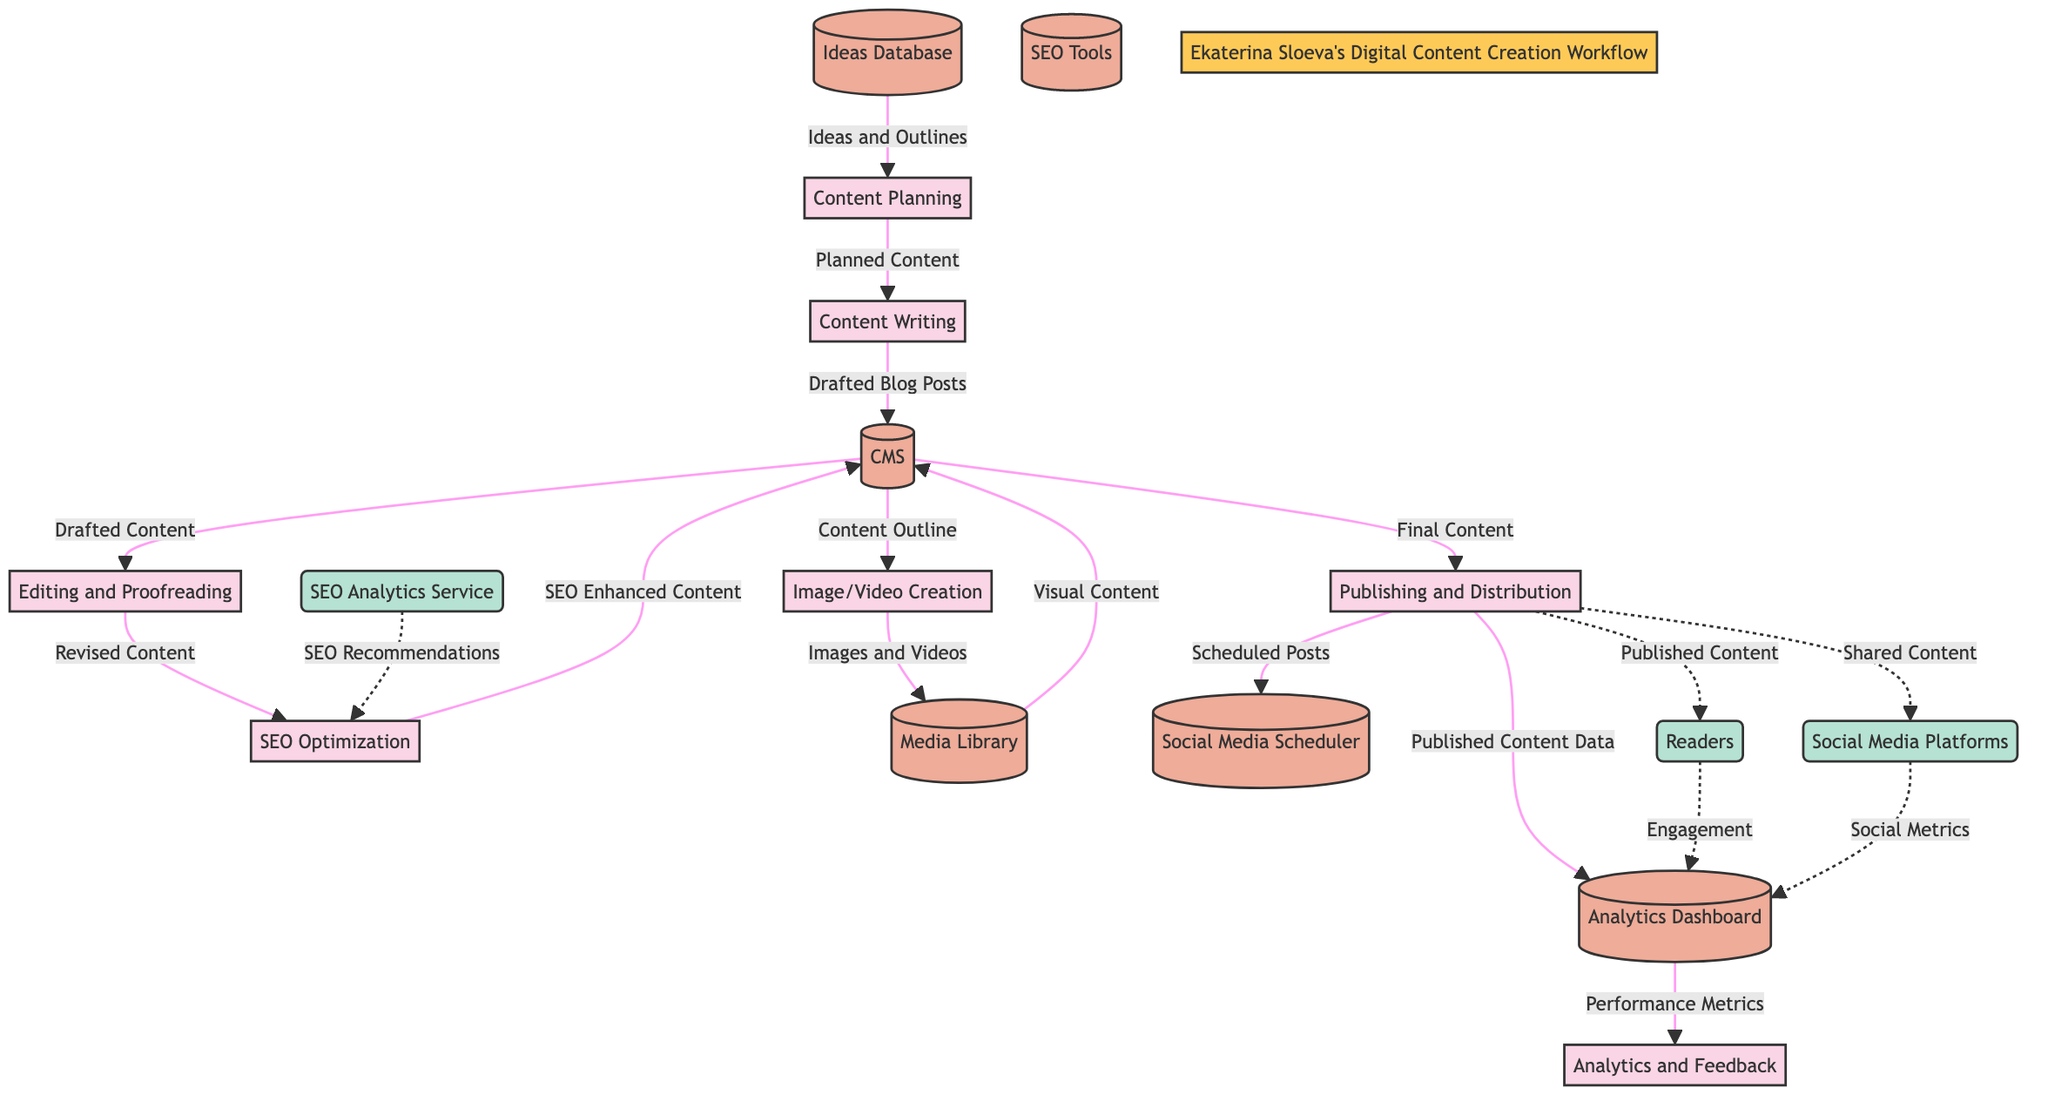What is the first process in the workflow? The first process indicated in the diagram is "Content Planning." It is the starting point before any other activities take place.
Answer: Content Planning How many data stores are present in the diagram? By counting the nodes labeled as data stores, we find that there are six data stores listed in the diagram.
Answer: 6 What data flows from the CMS to the Image/Video Creation process? The data flowing from the CMS to the Image/Video Creation process is labeled "Content Outline." This flow indicates what information is passed on to create visual elements.
Answer: Content Outline Which external entity receives the published content? The external entity that receives the published content is identified as "Readers." This entity represents the audience engaging with the blog posts.
Answer: Readers What is the final process before the Publishing and Distribution step? The final process before the Publishing and Distribution step in the workflow is "SEO Optimization." This indicates that the content must be optimized for search engines prior to being published.
Answer: SEO Optimization What does the Analytics Dashboard receive from the Publishing and Distribution process? The Analytics Dashboard receives "Published Content Data" from the Publishing and Distribution process. This data is essential for tracking performance metrics.
Answer: Published Content Data Which two processes are directly linked to the SEO Optimization store? The processes directly linked to the SEO Optimization store are "Editing and Proofreading" and "SEO Enhanced Content," indicating that revised content flows into the SEO process after editing.
Answer: Editing and Proofreading, SEO Enhanced Content What is the relationship between the Analytics Dashboard and the Analytics and Feedback process? The Analytics Dashboard provides "Performance Metrics" to the Analytics and Feedback process, indicating that the analysis of metrics is essential for feedback and future improvements.
Answer: Performance Metrics 